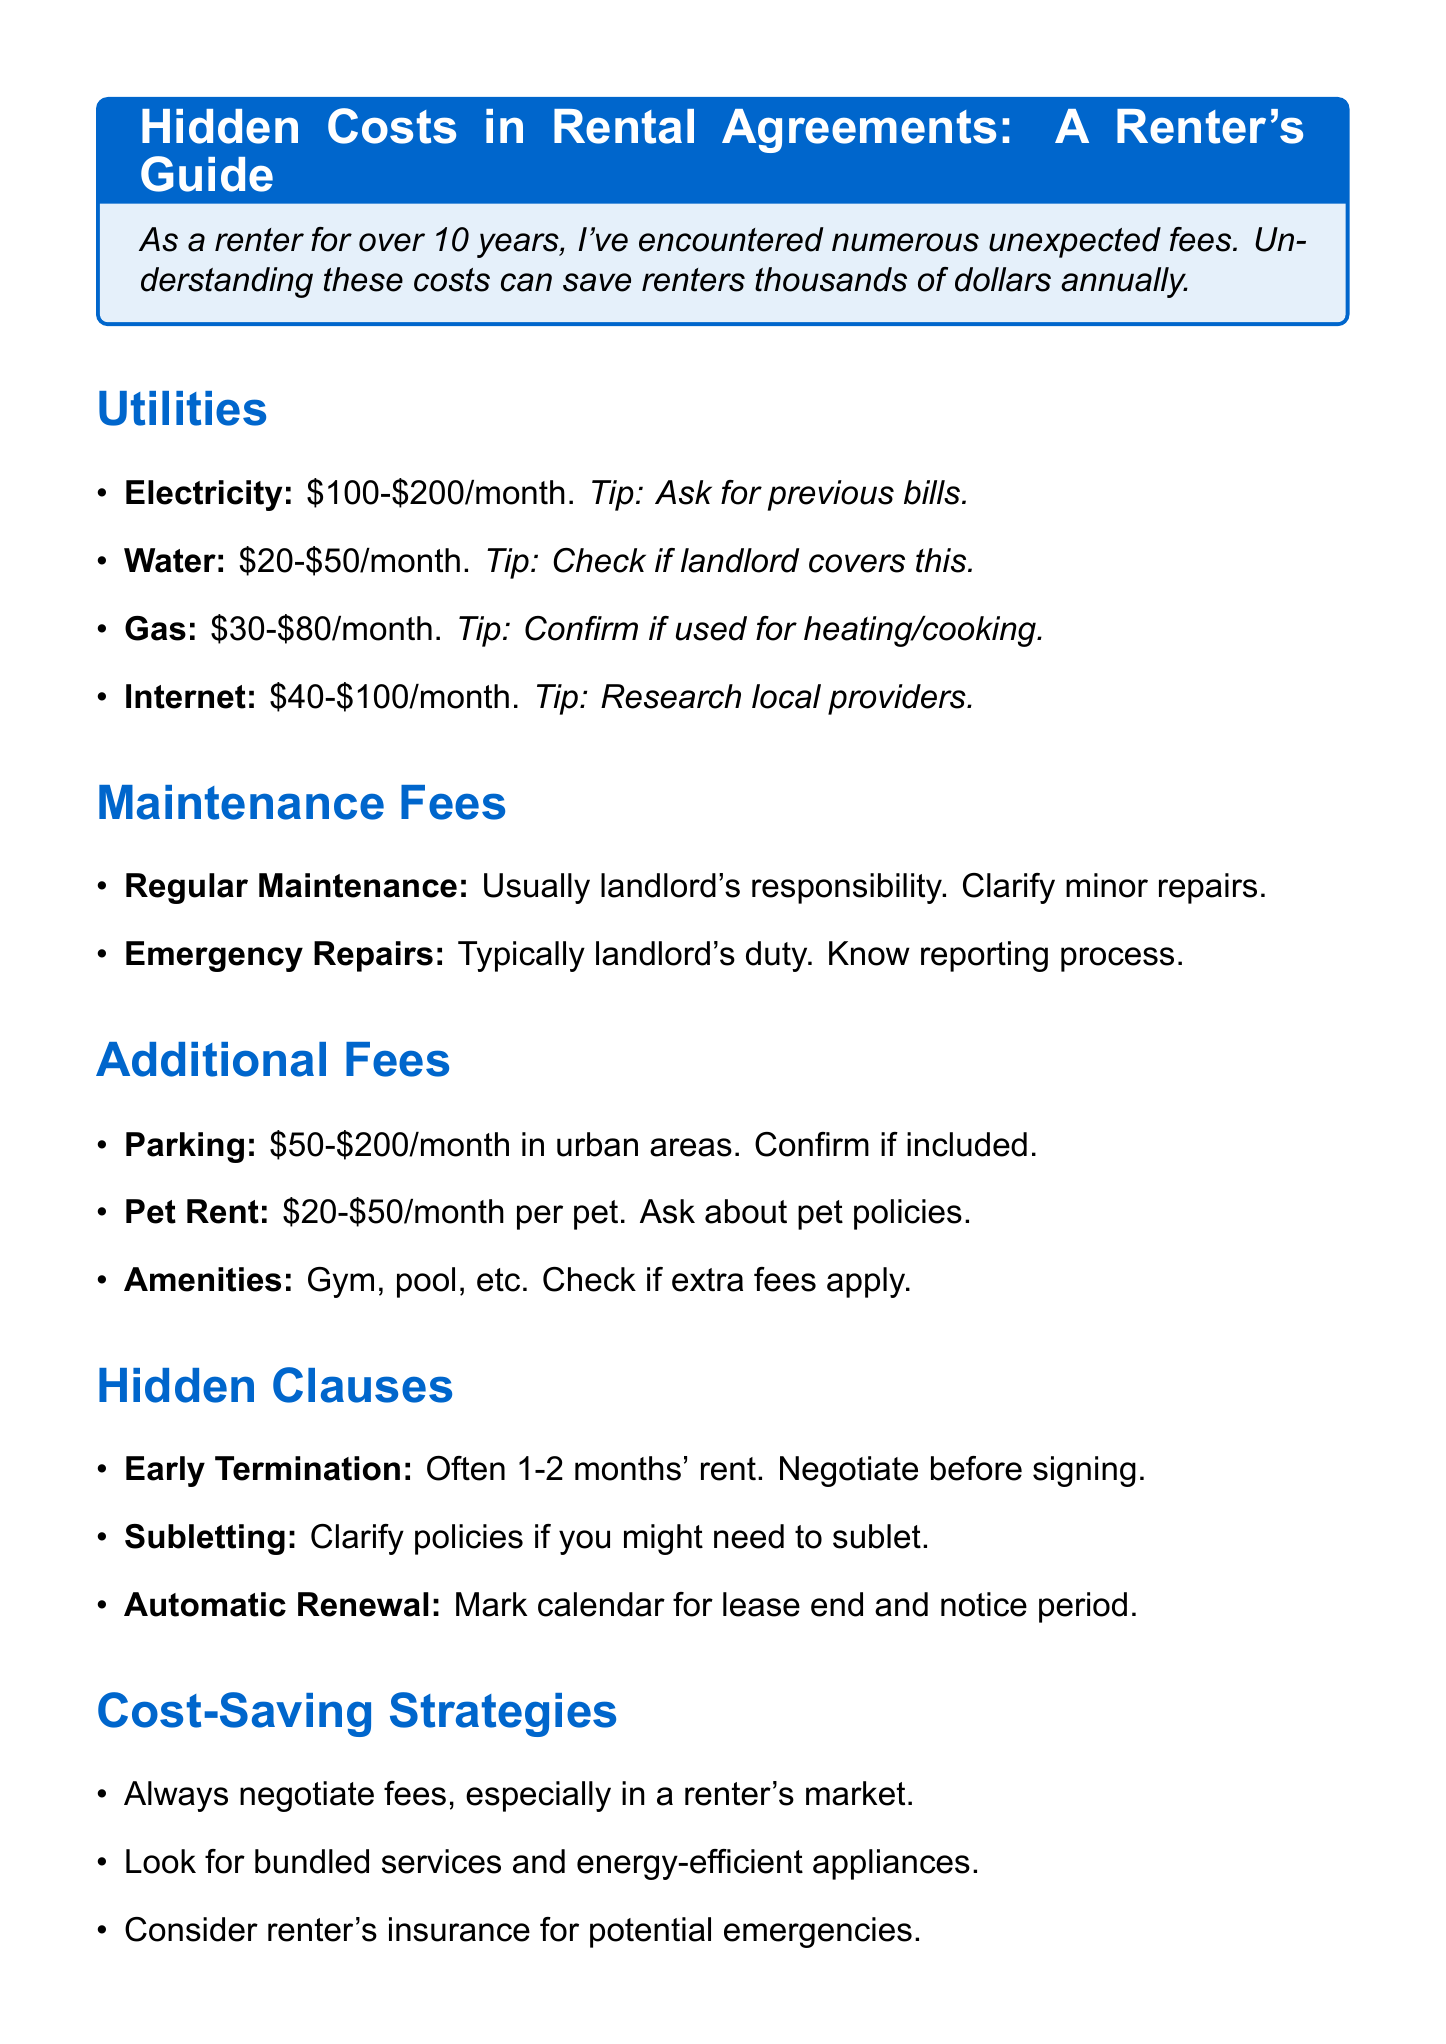What is the average monthly cost for electricity? The average monthly cost for electricity is provided in the utilities section, which is $100-$200.
Answer: $100-$200 Who is typically responsible for emergency repairs? The document states that emergency repairs are typically the landlord's responsibility.
Answer: Landlord What is the typical cost range for pet rent? The average cost for pet rent is listed in the additional fees section, which is $20-$50 per month per pet.
Answer: $20-$50 What should you do if you might need to sublet the property? The document advises to clarify policies regarding subletting if you might need to do so in the future.
Answer: Clarify policies What is suggested to potentially save on utility costs? The cost-saving strategies section mentions looking for energy-efficient appliances as a way to potentially save on utility costs.
Answer: Energy-efficient appliances How much can fees for early termination of lease range? The document specifies that early termination fees can range from 1-2 months' rent.
Answer: 1-2 months' rent What is a tip for negotiating rental fees? The cost-saving strategies section suggests always trying to negotiate fees, especially in a renter's market.
Answer: Negotiate fees What should you mark your calendar for related to automatic renewal? The document states you should mark your calendar for the lease end date and required notice period concerning automatic renewal.
Answer: Lease end date What kind of deals might some landlords offer for utilities? The document suggests that some landlords might offer package deals for utilities and internet.
Answer: Package deals 